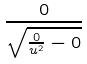<formula> <loc_0><loc_0><loc_500><loc_500>\frac { 0 } { \sqrt { \frac { 0 } { u ^ { 2 } } - 0 } }</formula> 